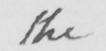What does this handwritten line say? the 